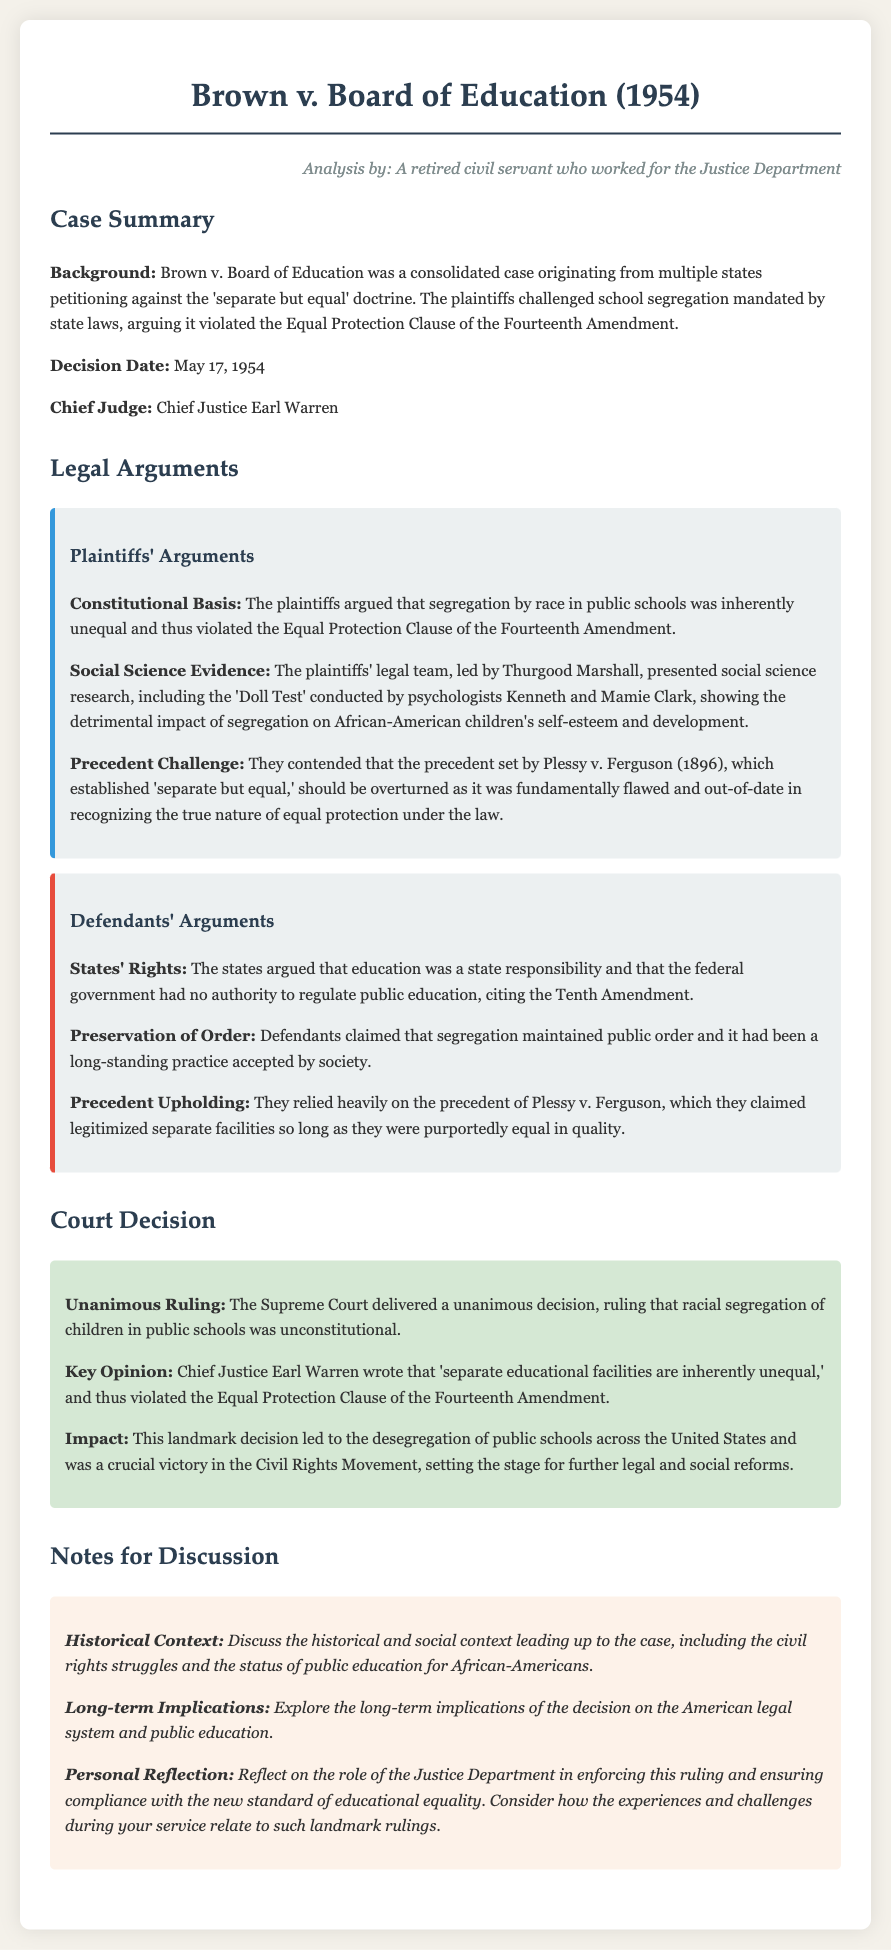What was the date of the decision? The document states that the decision date for Brown v. Board of Education was May 17, 1954.
Answer: May 17, 1954 Who was the Chief Judge in the case? The name of the Chief Judge is provided in the document as Chief Justice Earl Warren.
Answer: Chief Justice Earl Warren What were plaintiffs attempting to challenge? The plaintiffs were challenging the 'separate but equal' doctrine mandated by state laws concerning school segregation.
Answer: 'Separate but equal' doctrine What type of evidence did the plaintiffs present? The plaintiffs presented social science research, particularly the 'Doll Test' conducted by Kenneth and Mamie Clark.
Answer: 'Doll Test' What amendment was cited by the plaintiffs regarding equal protection? The plaintiffs referred to the Fourteenth Amendment in relation to equal protection.
Answer: Fourteenth Amendment What did the defendants argue regarding education? The defendants contended that education was a state responsibility, citing the Tenth Amendment.
Answer: States' rights What was the Supreme Court's ruling regarding public school segregation? The document indicates that the Supreme Court ruled that racial segregation of children in public schools was unconstitutional.
Answer: Unconstitutional How did the court characterize separate educational facilities? The court ruled that 'separate educational facilities are inherently unequal,' according to Chief Justice Earl Warren's opinion.
Answer: Inherently unequal What impact did the ruling have on public schools in the U.S.? The decision led to the desegregation of public schools across the United States.
Answer: Desegregation of public schools 